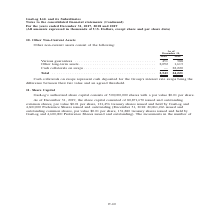According to Gaslog's financial document, What does cash collaterals on swaps represent? Cash collaterals on swaps represent cash deposited for the Group’s interest rate swaps being the difference between their fair value and an agreed threshold.. The document states: "Cash collaterals on swaps represent cash deposited for the Group’s interest rate swaps being the difference between their fair value and an agreed thr..." Also, In which year was the other non-current assets recorded for? The document shows two values: 2019 and 2018. From the document: ") For the years ended December 31, 2017, 2018 and 2019 (All amounts expressed in thousands of U.S. Dollars, except share and per share data) Continued..." Also, What was the amount of cash collaterals on swaps in 2019? According to the financial document, 22,220 (in thousands). The relevant text states: "ssets . 2,092 1,613 Cash collaterals on swaps . — 22,220..." Additionally, In which year was the other long-term assets higher? According to the financial document, 2018. The relevant text states: "Continued) For the years ended December 31, 2017, 2018 and 2019 (All amounts expressed in thousands of U.S. Dollars, except share and per share data)..." Also, can you calculate: What was the change in various guarantees from 2018 to 2019? Based on the calculation: 388 - 451 , the result is -63 (in thousands). This is based on the information: "Various guarantees . 451 388 Other long-term assets . 2,092 1,613 Cash collaterals on swaps . — 22,220 Various guarantees . 451 388 Other long-term assets . 2,092 1,613 Cash collaterals on swaps . — 2..." The key data points involved are: 388, 451. Also, can you calculate: What was the percentage change in total other non-current assets from 2018 to 2019? To answer this question, I need to perform calculations using the financial data. The calculation is: (24,221 - 2,543)/2,543 , which equals 852.46 (percentage). This is based on the information: "Total . 2,543 24,221 Total . 2,543 24,221..." The key data points involved are: 2,543, 24,221. 